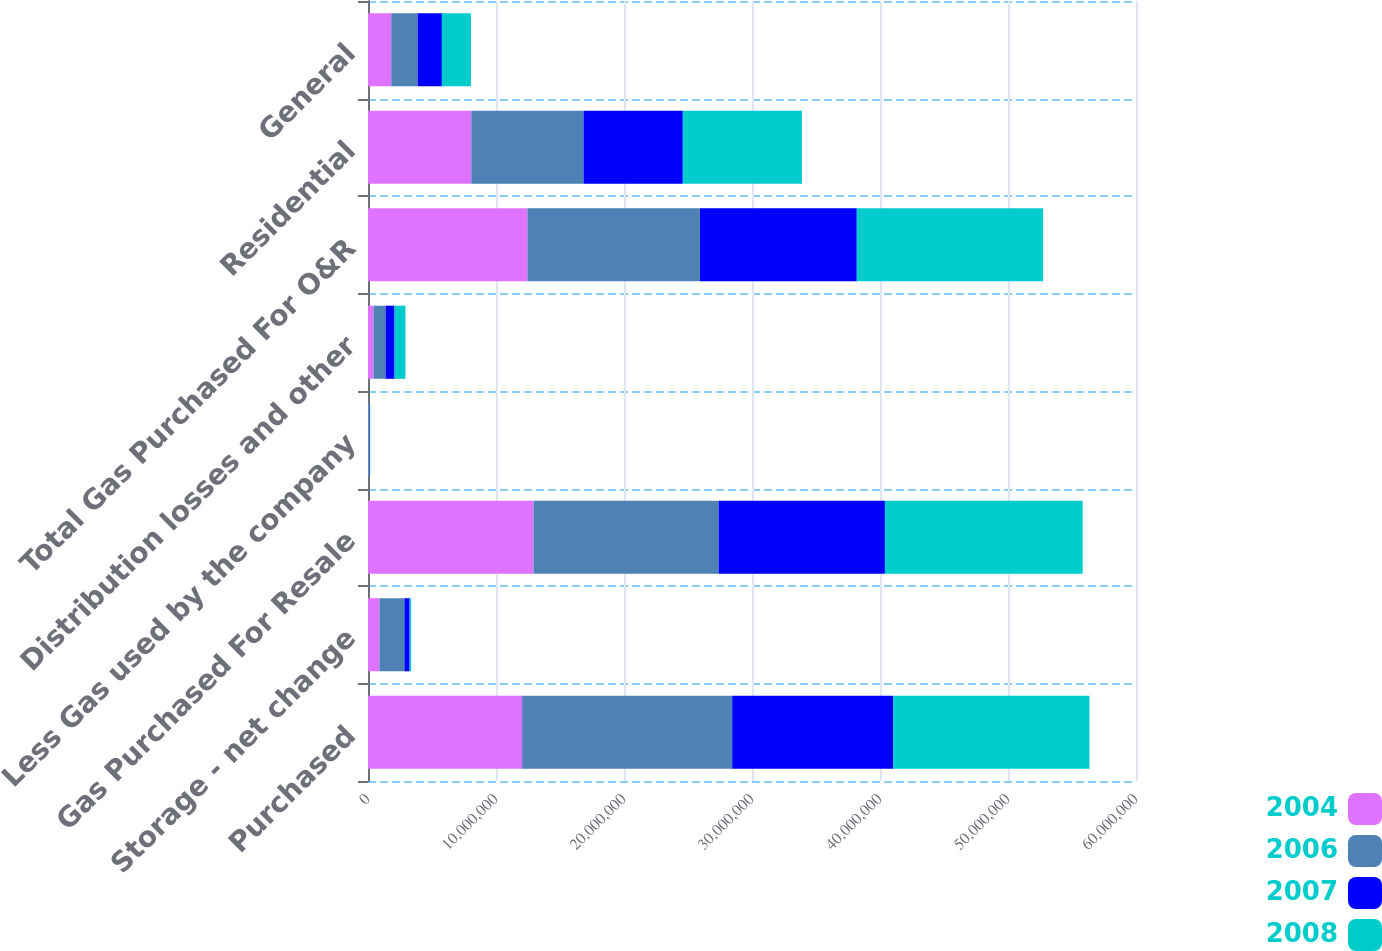Convert chart. <chart><loc_0><loc_0><loc_500><loc_500><stacked_bar_chart><ecel><fcel>Purchased<fcel>Storage - net change<fcel>Gas Purchased For Resale<fcel>Less Gas used by the company<fcel>Distribution losses and other<fcel>Total Gas Purchased For O&R<fcel>Residential<fcel>General<nl><fcel>2004<fcel>1.20388e+07<fcel>892058<fcel>1.29308e+07<fcel>46232<fcel>433738<fcel>1.24509e+07<fcel>8.06817e+06<fcel>1.816e+06<nl><fcel>2006<fcel>1.64127e+07<fcel>1.95096e+06<fcel>1.44618e+07<fcel>38268<fcel>937526<fcel>1.3486e+07<fcel>8.76883e+06<fcel>2.06563e+06<nl><fcel>2007<fcel>1.25824e+07<fcel>409333<fcel>1.29917e+07<fcel>37630<fcel>703676<fcel>1.22504e+07<fcel>7.75844e+06<fcel>1.89156e+06<nl><fcel>2008<fcel>1.53298e+07<fcel>121547<fcel>1.54514e+07<fcel>48410<fcel>848790<fcel>1.45542e+07<fcel>9.30659e+06<fcel>2.26921e+06<nl></chart> 